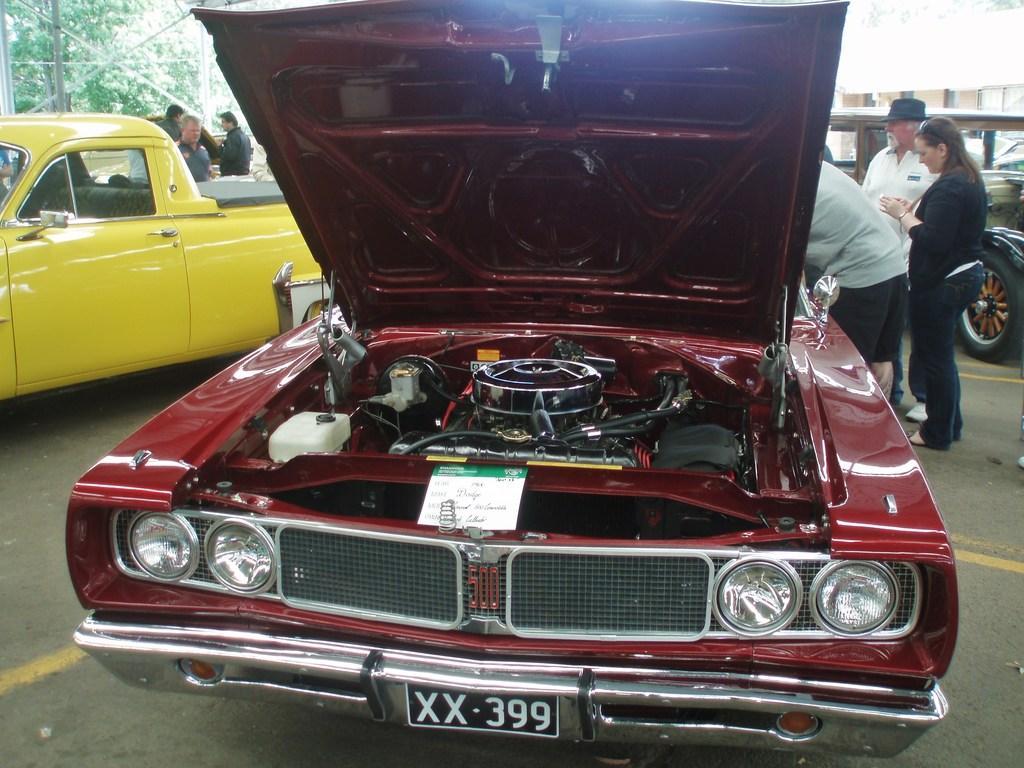Please provide a concise description of this image. In the center of the image there is a car. On the right side of the image we can see the persons standing at the car. On the left side of the image we can see the car on the road and persons standing at the car. In the background there is a car, building and trees. 